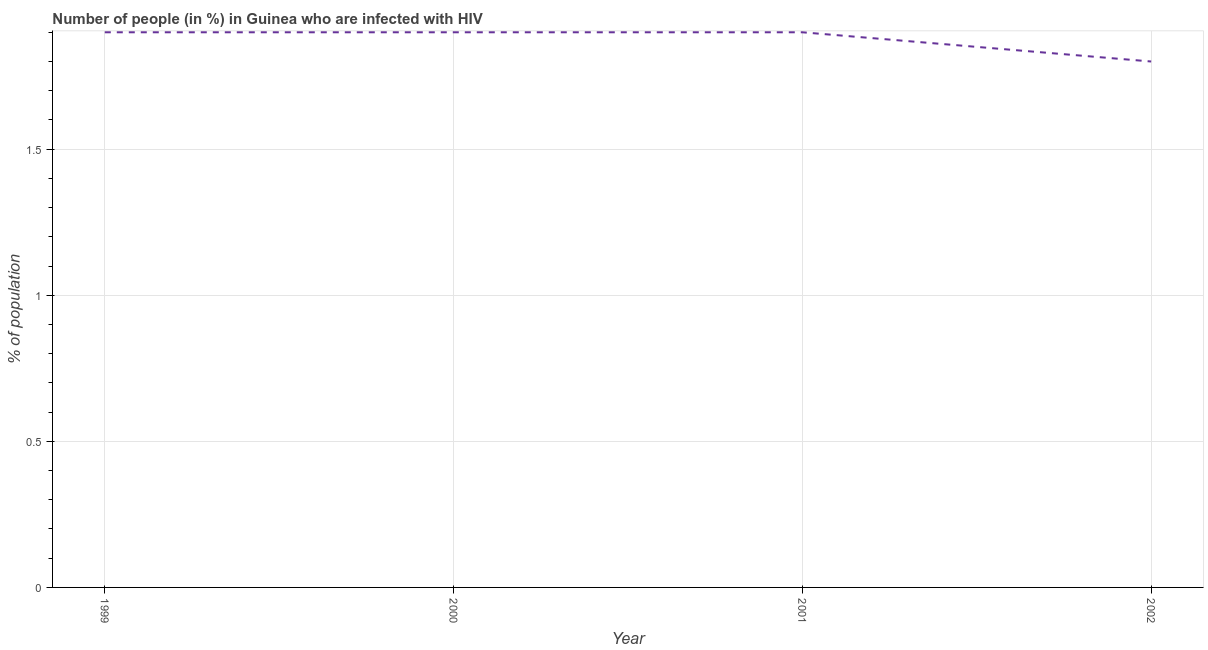In which year was the number of people infected with hiv maximum?
Give a very brief answer. 1999. What is the sum of the number of people infected with hiv?
Provide a short and direct response. 7.5. What is the difference between the number of people infected with hiv in 2001 and 2002?
Offer a terse response. 0.1. What is the average number of people infected with hiv per year?
Give a very brief answer. 1.87. In how many years, is the number of people infected with hiv greater than 0.5 %?
Keep it short and to the point. 4. Do a majority of the years between 2000 and 2002 (inclusive) have number of people infected with hiv greater than 1.2 %?
Keep it short and to the point. Yes. What is the ratio of the number of people infected with hiv in 1999 to that in 2000?
Your response must be concise. 1. What is the difference between the highest and the second highest number of people infected with hiv?
Provide a short and direct response. 0. What is the difference between the highest and the lowest number of people infected with hiv?
Offer a terse response. 0.1. How many years are there in the graph?
Keep it short and to the point. 4. Does the graph contain any zero values?
Offer a very short reply. No. What is the title of the graph?
Your answer should be compact. Number of people (in %) in Guinea who are infected with HIV. What is the label or title of the Y-axis?
Make the answer very short. % of population. What is the % of population of 2001?
Give a very brief answer. 1.9. What is the difference between the % of population in 1999 and 2000?
Your response must be concise. 0. What is the difference between the % of population in 1999 and 2001?
Provide a succinct answer. 0. What is the difference between the % of population in 1999 and 2002?
Give a very brief answer. 0.1. What is the difference between the % of population in 2000 and 2001?
Your answer should be very brief. 0. What is the difference between the % of population in 2000 and 2002?
Ensure brevity in your answer.  0.1. What is the difference between the % of population in 2001 and 2002?
Provide a succinct answer. 0.1. What is the ratio of the % of population in 1999 to that in 2002?
Keep it short and to the point. 1.06. What is the ratio of the % of population in 2000 to that in 2001?
Provide a short and direct response. 1. What is the ratio of the % of population in 2000 to that in 2002?
Offer a terse response. 1.06. What is the ratio of the % of population in 2001 to that in 2002?
Keep it short and to the point. 1.06. 